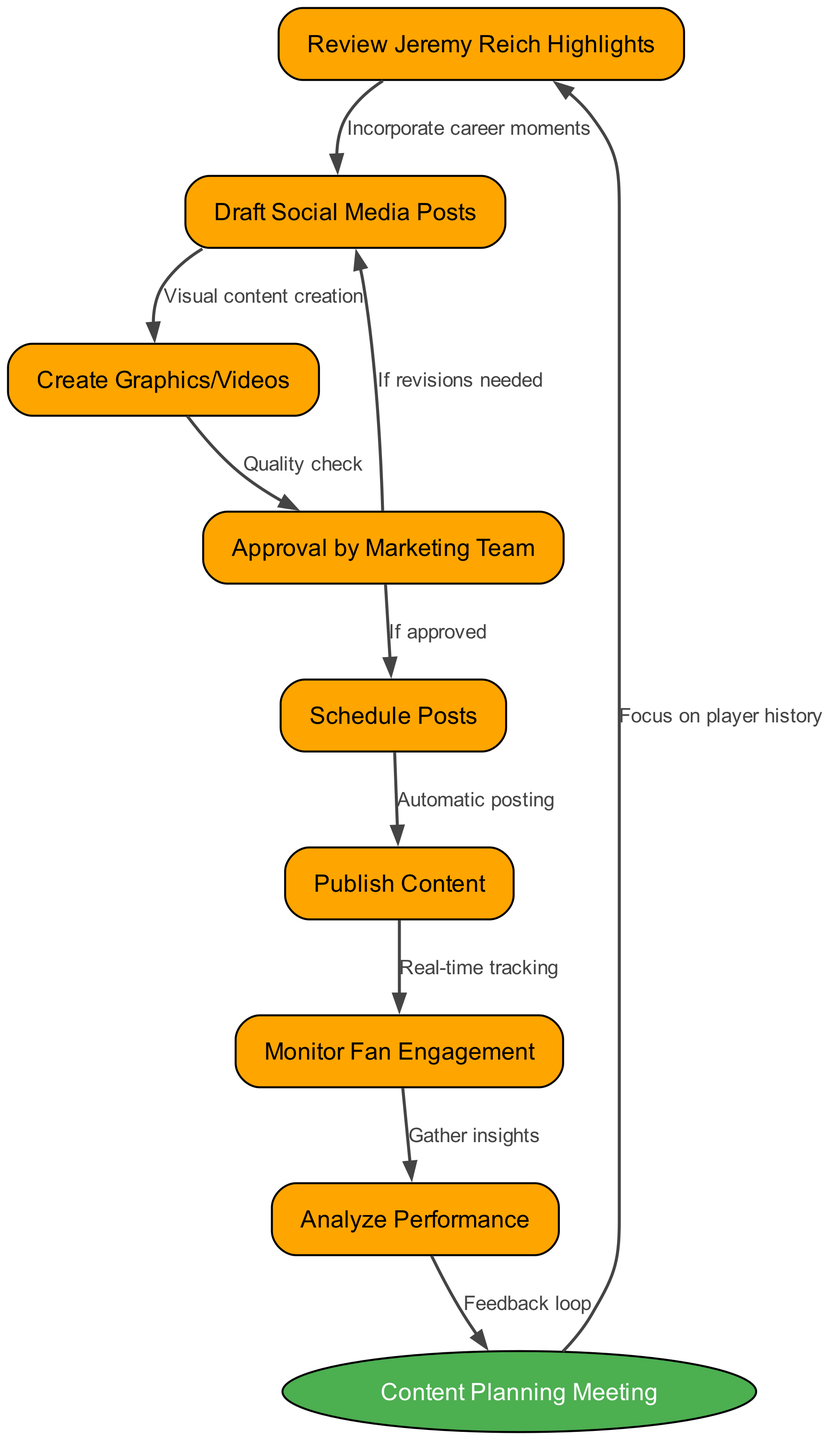What is the starting node of the workflow? The starting node is explicitly labeled as "Content Planning Meeting" in the diagram, which serves as the entry point for the workflow.
Answer: Content Planning Meeting How many nodes are there in total? By counting all the nodes provided in the data, including the starting node, we find there are a total of 8 nodes: the starting node plus 7 additional nodes.
Answer: 8 What happens after the "Approval by Marketing Team" if revisions are needed? According to the edge in the diagram labeled "If revisions needed," the workflow loops back to "Draft Social Media Posts," indicating that revisions will lead to redrafting.
Answer: Draft Social Media Posts Which node follows "Create Graphics/Videos" in the workflow? The diagram shows an arrow from "Create Graphics/Videos" to "Approval by Marketing Team," indicating that this is the next step in the process after creating the content.
Answer: Approval by Marketing Team How many edges are present in the diagram? By counting the relationships (or edges) defined in the data, there are a total of 9 edges connecting the nodes in the workflow.
Answer: 9 What is the purpose of the "Monitor Fan Engagement" node? The diagram shows that "Monitor Fan Engagement" connects to "Analyze Performance," indicating that its purpose is to track engagement levels, which then informs performance analysis.
Answer: Gather insights What leads to the "Schedule Posts" node in the workflow? The "Schedule Posts" node is only reached if the "Approval by Marketing Team" gives approval, as shown in the edge labeled "If approved."
Answer: Approval by Marketing Team What is the relationship between "Analyze Performance" and the "Content Planning Meeting"? The diagram indicates a feedback loop by connecting "Analyze Performance" back to "Content Planning Meeting," highlighting that performance analysis informs future content planning.
Answer: Feedback loop What type of content is created in the "Create Graphics/Videos" step? The description of this step indicates that visual content is being created, which can include both graphics and videos related to the Syracuse Crunch.
Answer: Visual content creation 